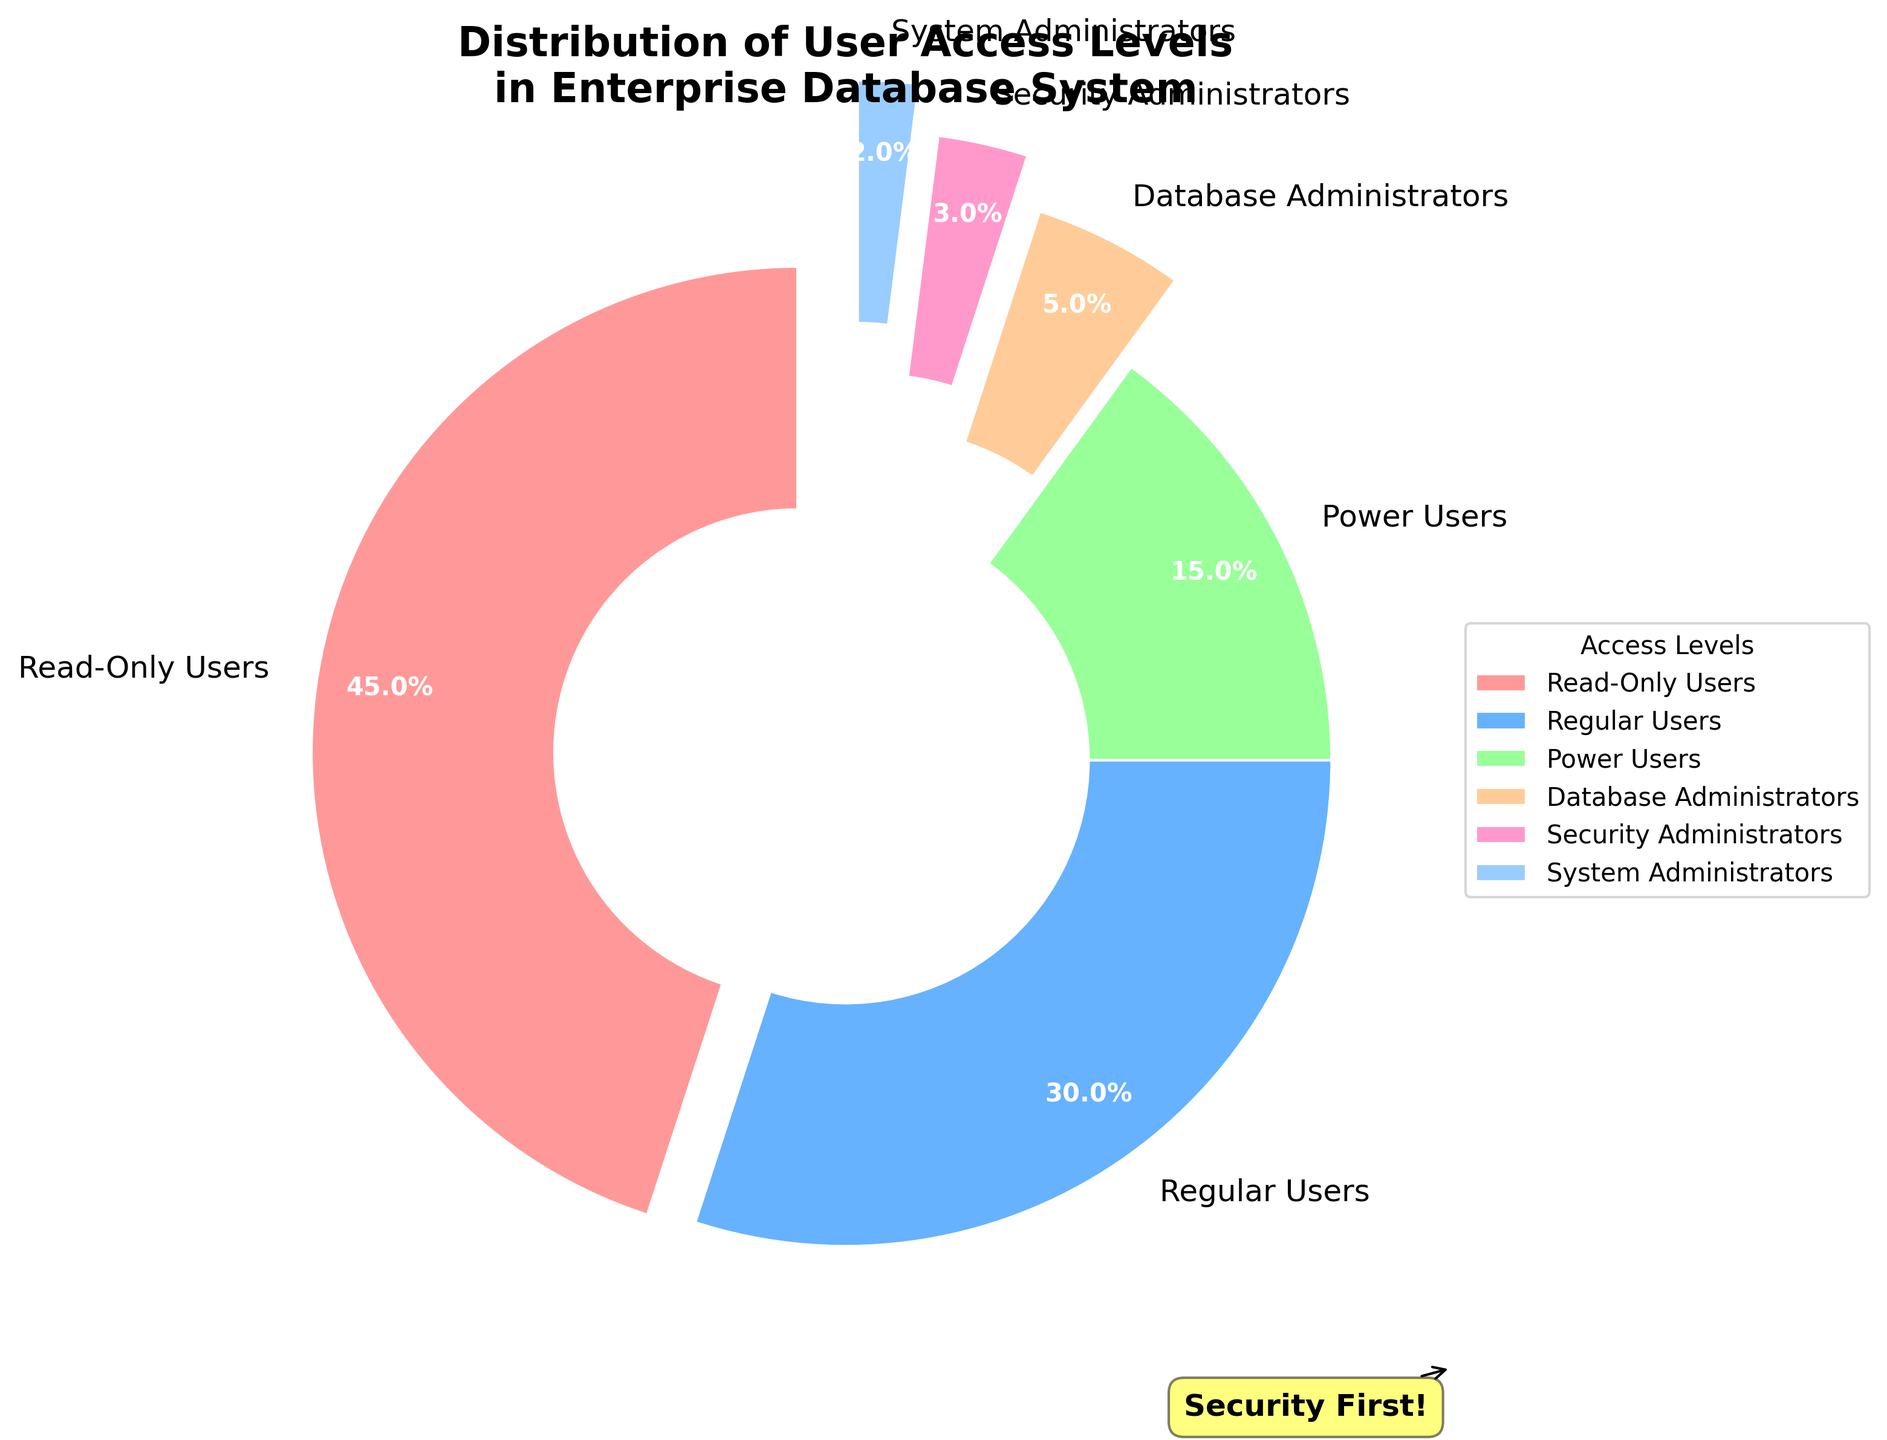Which access level has the largest percentage of users? The largest section of the pie chart corresponds to "Read-Only Users," which has the highest percentage.
Answer: Read-Only Users What is the combined percentage of Power Users, Database Administrators, and System Administrators? To find the combined percentage, add the percentages of Power Users (15%), Database Administrators (5%), and System Administrators (2%). Therefore, 15 + 5 + 2 = 22%.
Answer: 22% Which access level has the smallest share in the distribution? The smallest slice of the pie chart corresponds to "System Administrators," with a percentage of 2%.
Answer: System Administrators How does the percentage of Regular Users compare to that of Power Users? Regular Users have a 30% share, while Power Users have a 15% share. Thus, Regular Users have a higher percentage than Power Users.
Answer: Regular Users have a higher percentage What is the total percentage share of all administrator-level users combined (Database Administrators, Security Administrators, System Administrators)? To find the total share of all administrator-level users, add their percentages: Database Administrators (5%), Security Administrators (3%), and System Administrators (2%). The sum is 5 + 3 + 2 = 10%.
Answer: 10% What is the difference in the percentage share between Read-Only Users and Security Administrators? Subtract the percentage share of Security Administrators (3%) from that of Read-Only Users (45%). Therefore, 45 - 3 = 42%.
Answer: 42% What color represents Regular Users in the pie chart? The pie chart shows Regular Users in a blue color.
Answer: Blue If you combine Read-Only Users and Regular Users, what percentage of the user base do they constitute? Add the percentages for Read-Only Users (45%) and Regular Users (30%). The combined percentage is 45 + 30 = 75%.
Answer: 75% Which two access levels should be compared to see a 10% difference in their user share? Comparing Regular Users (30%) and Power Users (15%) shows a difference of 30 - 15 = 15%, while comparing Power Users (15%) and Database Administrators (5%) shows a difference of 15 - 5 = 10%.
Answer: Power Users and Database Administrators How is the slice representing Security Administrators visually distinguished from the other slices? The slice for Security Administrators is exploded (offset) more from the center compared to other slices for emphasis.
Answer: Exploded from the center 